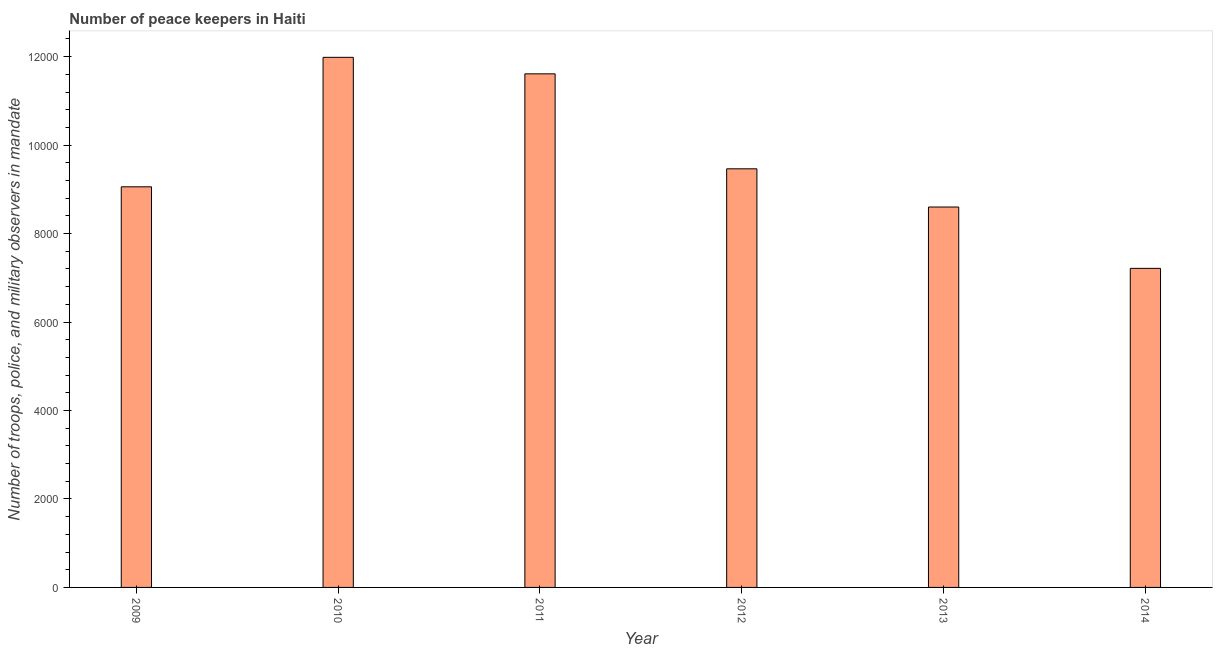Does the graph contain any zero values?
Your answer should be compact. No. What is the title of the graph?
Give a very brief answer. Number of peace keepers in Haiti. What is the label or title of the Y-axis?
Your response must be concise. Number of troops, police, and military observers in mandate. What is the number of peace keepers in 2012?
Provide a short and direct response. 9464. Across all years, what is the maximum number of peace keepers?
Provide a short and direct response. 1.20e+04. Across all years, what is the minimum number of peace keepers?
Your answer should be compact. 7213. In which year was the number of peace keepers maximum?
Give a very brief answer. 2010. What is the sum of the number of peace keepers?
Provide a short and direct response. 5.79e+04. What is the difference between the number of peace keepers in 2009 and 2010?
Keep it short and to the point. -2927. What is the average number of peace keepers per year?
Give a very brief answer. 9654. What is the median number of peace keepers?
Offer a terse response. 9260.5. In how many years, is the number of peace keepers greater than 9200 ?
Your answer should be very brief. 3. What is the ratio of the number of peace keepers in 2010 to that in 2013?
Offer a terse response. 1.39. Is the number of peace keepers in 2010 less than that in 2014?
Give a very brief answer. No. Is the difference between the number of peace keepers in 2010 and 2014 greater than the difference between any two years?
Make the answer very short. Yes. What is the difference between the highest and the second highest number of peace keepers?
Ensure brevity in your answer.  373. What is the difference between the highest and the lowest number of peace keepers?
Your response must be concise. 4771. In how many years, is the number of peace keepers greater than the average number of peace keepers taken over all years?
Offer a very short reply. 2. How many bars are there?
Keep it short and to the point. 6. Are all the bars in the graph horizontal?
Offer a terse response. No. How many years are there in the graph?
Your response must be concise. 6. Are the values on the major ticks of Y-axis written in scientific E-notation?
Give a very brief answer. No. What is the Number of troops, police, and military observers in mandate in 2009?
Your response must be concise. 9057. What is the Number of troops, police, and military observers in mandate in 2010?
Keep it short and to the point. 1.20e+04. What is the Number of troops, police, and military observers in mandate of 2011?
Keep it short and to the point. 1.16e+04. What is the Number of troops, police, and military observers in mandate of 2012?
Your answer should be very brief. 9464. What is the Number of troops, police, and military observers in mandate in 2013?
Your response must be concise. 8600. What is the Number of troops, police, and military observers in mandate of 2014?
Make the answer very short. 7213. What is the difference between the Number of troops, police, and military observers in mandate in 2009 and 2010?
Provide a short and direct response. -2927. What is the difference between the Number of troops, police, and military observers in mandate in 2009 and 2011?
Your response must be concise. -2554. What is the difference between the Number of troops, police, and military observers in mandate in 2009 and 2012?
Provide a succinct answer. -407. What is the difference between the Number of troops, police, and military observers in mandate in 2009 and 2013?
Provide a succinct answer. 457. What is the difference between the Number of troops, police, and military observers in mandate in 2009 and 2014?
Offer a very short reply. 1844. What is the difference between the Number of troops, police, and military observers in mandate in 2010 and 2011?
Your response must be concise. 373. What is the difference between the Number of troops, police, and military observers in mandate in 2010 and 2012?
Ensure brevity in your answer.  2520. What is the difference between the Number of troops, police, and military observers in mandate in 2010 and 2013?
Your answer should be very brief. 3384. What is the difference between the Number of troops, police, and military observers in mandate in 2010 and 2014?
Give a very brief answer. 4771. What is the difference between the Number of troops, police, and military observers in mandate in 2011 and 2012?
Your answer should be very brief. 2147. What is the difference between the Number of troops, police, and military observers in mandate in 2011 and 2013?
Your response must be concise. 3011. What is the difference between the Number of troops, police, and military observers in mandate in 2011 and 2014?
Your response must be concise. 4398. What is the difference between the Number of troops, police, and military observers in mandate in 2012 and 2013?
Keep it short and to the point. 864. What is the difference between the Number of troops, police, and military observers in mandate in 2012 and 2014?
Your answer should be very brief. 2251. What is the difference between the Number of troops, police, and military observers in mandate in 2013 and 2014?
Provide a short and direct response. 1387. What is the ratio of the Number of troops, police, and military observers in mandate in 2009 to that in 2010?
Provide a succinct answer. 0.76. What is the ratio of the Number of troops, police, and military observers in mandate in 2009 to that in 2011?
Your response must be concise. 0.78. What is the ratio of the Number of troops, police, and military observers in mandate in 2009 to that in 2013?
Make the answer very short. 1.05. What is the ratio of the Number of troops, police, and military observers in mandate in 2009 to that in 2014?
Give a very brief answer. 1.26. What is the ratio of the Number of troops, police, and military observers in mandate in 2010 to that in 2011?
Give a very brief answer. 1.03. What is the ratio of the Number of troops, police, and military observers in mandate in 2010 to that in 2012?
Your answer should be very brief. 1.27. What is the ratio of the Number of troops, police, and military observers in mandate in 2010 to that in 2013?
Ensure brevity in your answer.  1.39. What is the ratio of the Number of troops, police, and military observers in mandate in 2010 to that in 2014?
Your response must be concise. 1.66. What is the ratio of the Number of troops, police, and military observers in mandate in 2011 to that in 2012?
Provide a short and direct response. 1.23. What is the ratio of the Number of troops, police, and military observers in mandate in 2011 to that in 2013?
Your response must be concise. 1.35. What is the ratio of the Number of troops, police, and military observers in mandate in 2011 to that in 2014?
Provide a succinct answer. 1.61. What is the ratio of the Number of troops, police, and military observers in mandate in 2012 to that in 2014?
Provide a short and direct response. 1.31. What is the ratio of the Number of troops, police, and military observers in mandate in 2013 to that in 2014?
Your response must be concise. 1.19. 